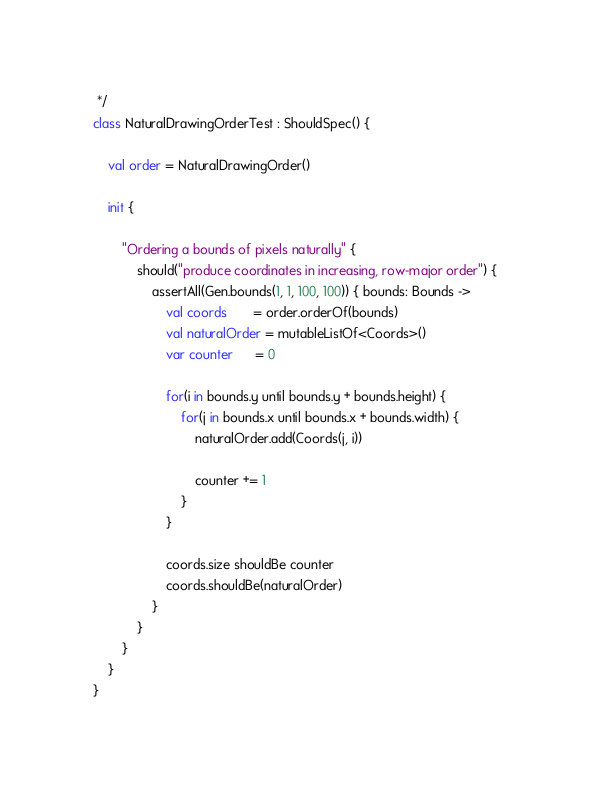<code> <loc_0><loc_0><loc_500><loc_500><_Kotlin_> */
class NaturalDrawingOrderTest : ShouldSpec() {

    val order = NaturalDrawingOrder()

    init {

        "Ordering a bounds of pixels naturally" {
            should("produce coordinates in increasing, row-major order") {
                assertAll(Gen.bounds(1, 1, 100, 100)) { bounds: Bounds ->
                    val coords       = order.orderOf(bounds)
                    val naturalOrder = mutableListOf<Coords>()
                    var counter      = 0

                    for(i in bounds.y until bounds.y + bounds.height) {
                        for(j in bounds.x until bounds.x + bounds.width) {
                            naturalOrder.add(Coords(j, i))

                            counter += 1
                        }
                    }

                    coords.size shouldBe counter
                    coords.shouldBe(naturalOrder)
                }
            }
        }
    }
}</code> 